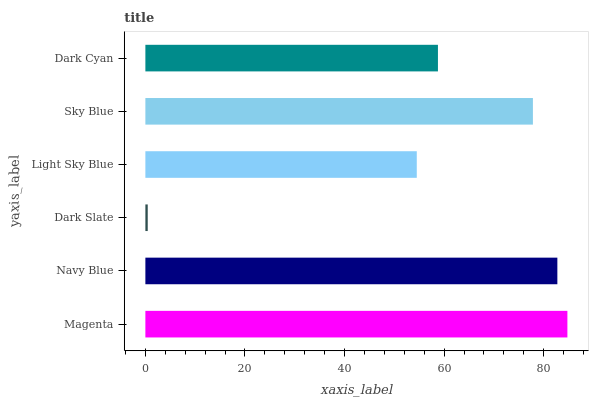Is Dark Slate the minimum?
Answer yes or no. Yes. Is Magenta the maximum?
Answer yes or no. Yes. Is Navy Blue the minimum?
Answer yes or no. No. Is Navy Blue the maximum?
Answer yes or no. No. Is Magenta greater than Navy Blue?
Answer yes or no. Yes. Is Navy Blue less than Magenta?
Answer yes or no. Yes. Is Navy Blue greater than Magenta?
Answer yes or no. No. Is Magenta less than Navy Blue?
Answer yes or no. No. Is Sky Blue the high median?
Answer yes or no. Yes. Is Dark Cyan the low median?
Answer yes or no. Yes. Is Dark Slate the high median?
Answer yes or no. No. Is Magenta the low median?
Answer yes or no. No. 